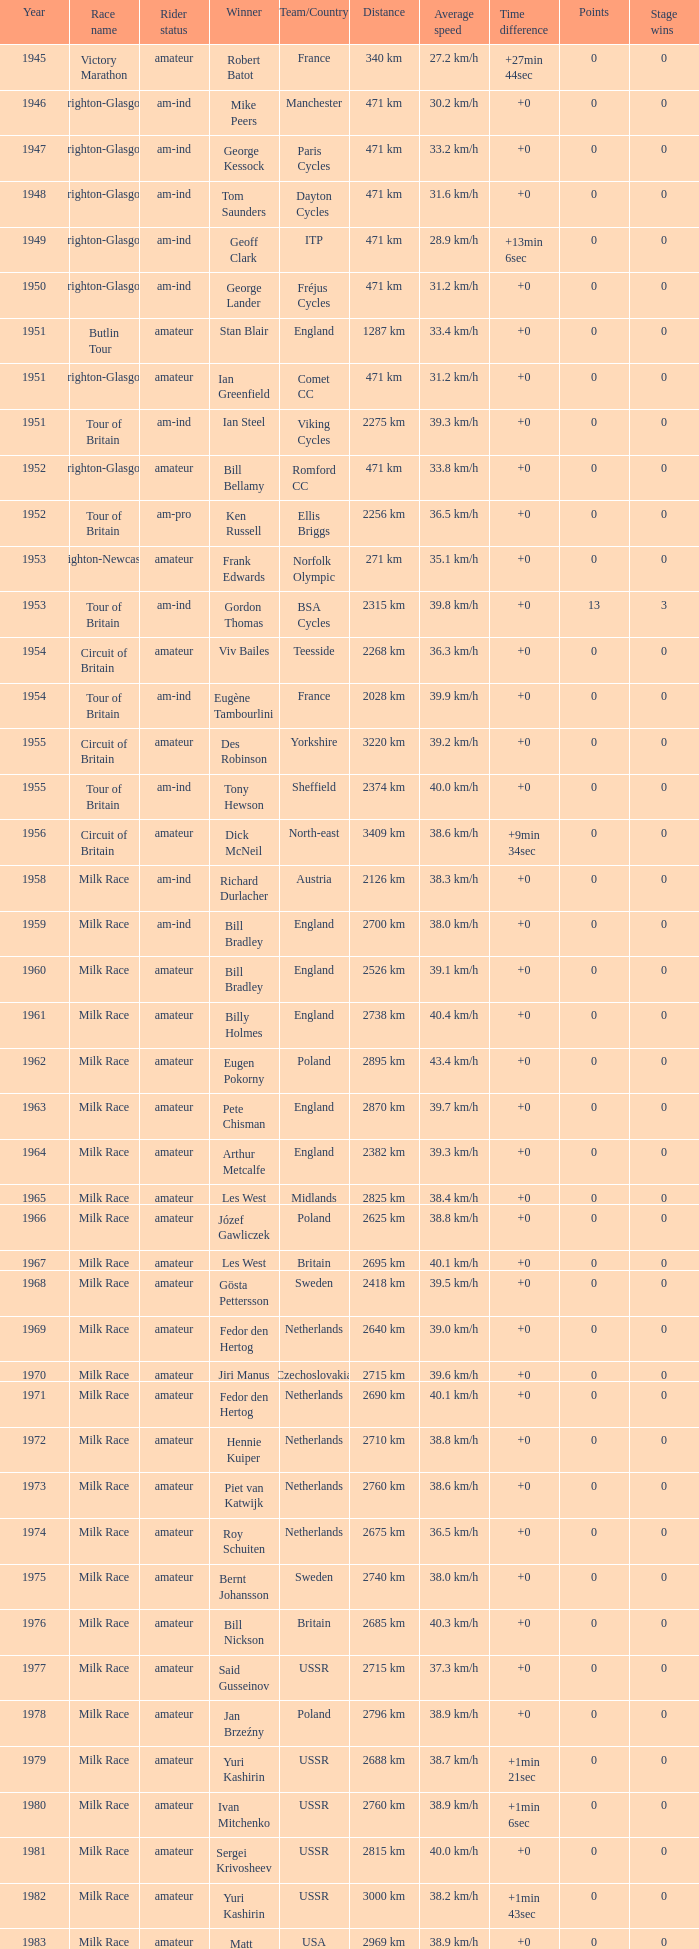What ream played later than 1958 in the kellogg's tour? ANC, Fagor, Z-Peugeot, Weinnmann-SMM, Motorola, Motorola, Motorola, Lampre. 